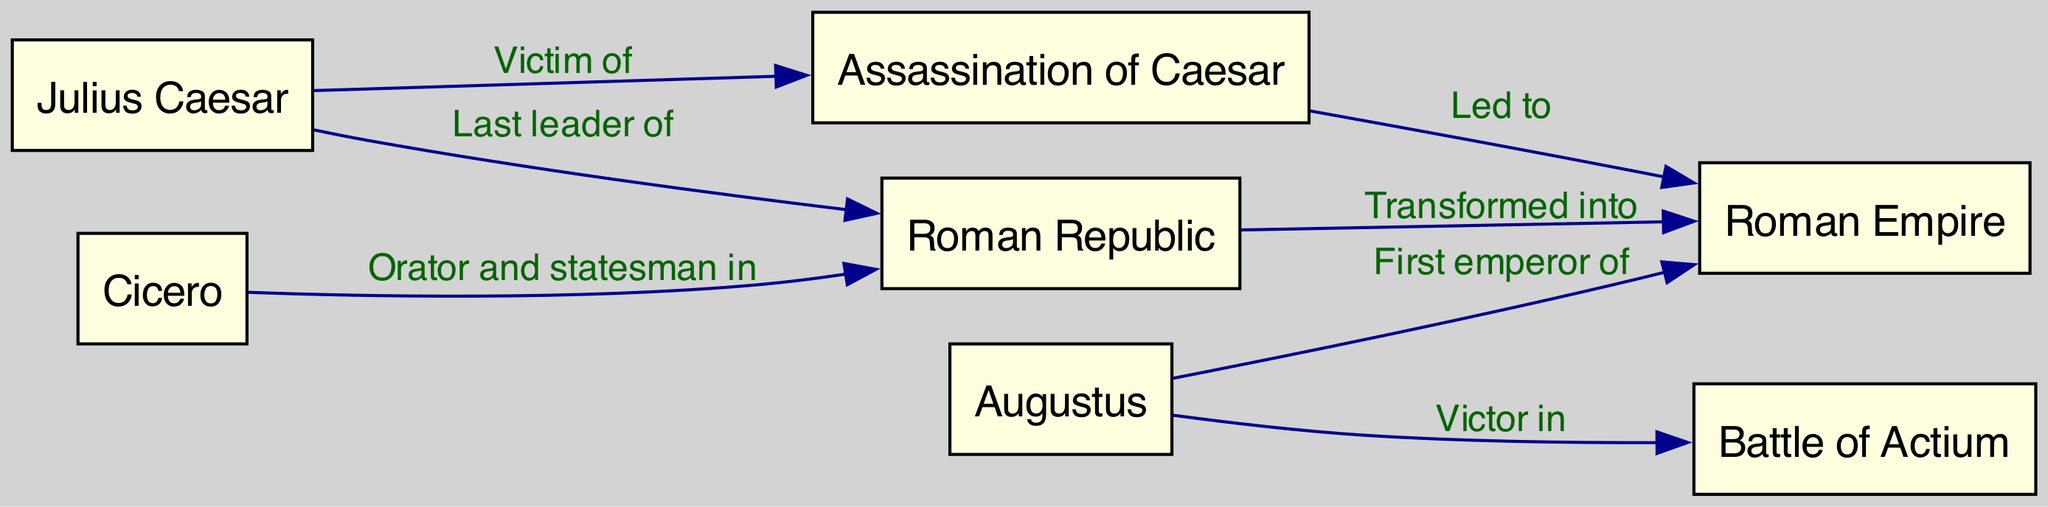What is the last leader of the Roman Republic? The diagram connects the node "Julius Caesar" to "Roman Republic" with the label "Last leader of." Therefore, the information directly states that Julius Caesar was the last leader.
Answer: Julius Caesar How did the assassination of Caesar affect the Roman Empire? The edge labeled "Led to" connects "Assassination of Caesar" to "Roman Empire." This indicates that the assassination was a significant event that contributed to the formation or transformation of the Roman Empire.
Answer: Led to Who was the first emperor of the Roman Empire? The edge labeled "First emperor of" connects "Augustus" to "Roman Empire." This specifies that Augustus is recognized as the first emperor, providing a clear answer regarding his role in Roman history.
Answer: Augustus What battle did Augustus win? The connection from "Augustus" to "Battle of Actium" is described with the label "Victor in." This indicates that Augustus was victorious in this specific battle, allowing us to identify it directly.
Answer: Battle of Actium Which notable orator and statesman was associated with the Roman Republic? The relationship between "Cicero" and "Roman Republic" is labeled "Orator and statesman in," meaning Cicero is the figure in question who played a significant role during the period of the Republic.
Answer: Cicero How many nodes are present in this concept map? The concept map contains a total of six nodes: Julius Caesar, Augustus, Cicero, Roman Republic, Roman Empire, and Assassination of Caesar. By counting all unique nodes in the data, we arrive at this number.
Answer: 6 How many edges connect the nodes in this diagram? The data includes a total of six edges, which serve as the relationships between the nodes. By counting all edges in the provided data, we find the number of connections in the concept map.
Answer: 6 What transformation did the Roman Republic undergo? The diagram indicates a connection from "Roman Republic" to "Roman Empire" labeled "Transformed into." This phrase indicates a specific change from one form of governance to another, signaling the evolution of Rome's political structure.
Answer: Transformed into What was the fate of Julius Caesar? The node "Assassination of Caesar" has an edge connecting from "Julius Caesar" with the label "Victim of." This establishes that Julius Caesar met his demise through assassination, clearly outlining the consequence of his leadership.
Answer: Victim of 